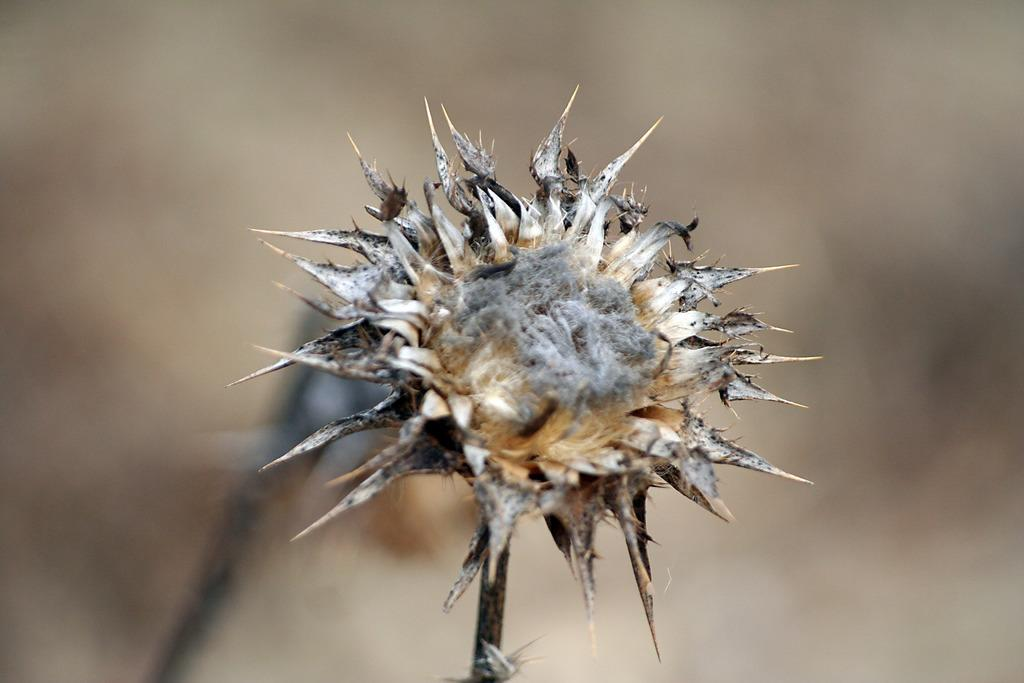What type of plant is present in the image? There is a dried flower in the image. Can you see a horse in the image? No, there is no horse present in the image; it only features a dried flower. 